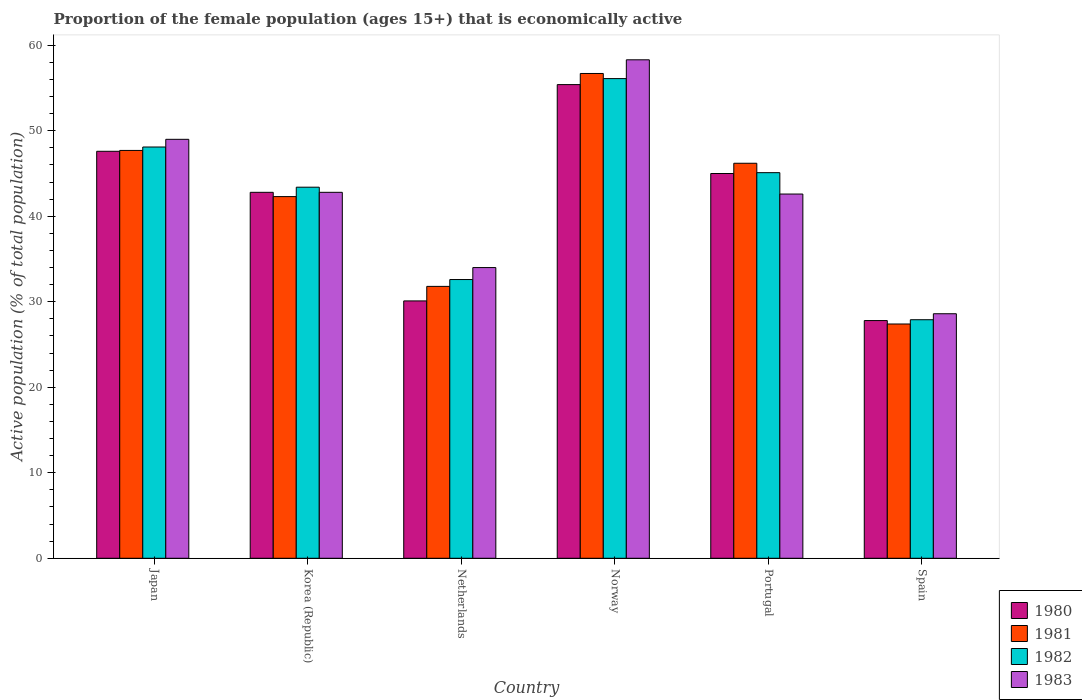How many different coloured bars are there?
Offer a terse response. 4. How many groups of bars are there?
Make the answer very short. 6. Are the number of bars per tick equal to the number of legend labels?
Offer a terse response. Yes. How many bars are there on the 3rd tick from the right?
Ensure brevity in your answer.  4. What is the label of the 6th group of bars from the left?
Offer a very short reply. Spain. In how many cases, is the number of bars for a given country not equal to the number of legend labels?
Offer a terse response. 0. What is the proportion of the female population that is economically active in 1983 in Netherlands?
Your response must be concise. 34. Across all countries, what is the maximum proportion of the female population that is economically active in 1980?
Offer a very short reply. 55.4. Across all countries, what is the minimum proportion of the female population that is economically active in 1983?
Provide a succinct answer. 28.6. In which country was the proportion of the female population that is economically active in 1982 minimum?
Your answer should be very brief. Spain. What is the total proportion of the female population that is economically active in 1982 in the graph?
Offer a very short reply. 253.2. What is the difference between the proportion of the female population that is economically active in 1981 in Norway and that in Portugal?
Provide a succinct answer. 10.5. What is the difference between the proportion of the female population that is economically active in 1983 in Portugal and the proportion of the female population that is economically active in 1980 in Korea (Republic)?
Your response must be concise. -0.2. What is the average proportion of the female population that is economically active in 1981 per country?
Your answer should be compact. 42.02. What is the difference between the proportion of the female population that is economically active of/in 1980 and proportion of the female population that is economically active of/in 1981 in Japan?
Make the answer very short. -0.1. What is the ratio of the proportion of the female population that is economically active in 1983 in Korea (Republic) to that in Norway?
Keep it short and to the point. 0.73. Is the proportion of the female population that is economically active in 1982 in Japan less than that in Spain?
Your answer should be very brief. No. What is the difference between the highest and the second highest proportion of the female population that is economically active in 1983?
Offer a terse response. -9.3. What is the difference between the highest and the lowest proportion of the female population that is economically active in 1982?
Your answer should be compact. 28.2. Is it the case that in every country, the sum of the proportion of the female population that is economically active in 1983 and proportion of the female population that is economically active in 1982 is greater than the sum of proportion of the female population that is economically active in 1980 and proportion of the female population that is economically active in 1981?
Keep it short and to the point. No. What does the 1st bar from the right in Netherlands represents?
Make the answer very short. 1983. How many bars are there?
Offer a very short reply. 24. Are all the bars in the graph horizontal?
Your answer should be very brief. No. How many countries are there in the graph?
Offer a terse response. 6. What is the difference between two consecutive major ticks on the Y-axis?
Offer a terse response. 10. Does the graph contain grids?
Give a very brief answer. No. How many legend labels are there?
Offer a terse response. 4. What is the title of the graph?
Provide a succinct answer. Proportion of the female population (ages 15+) that is economically active. Does "1986" appear as one of the legend labels in the graph?
Provide a short and direct response. No. What is the label or title of the Y-axis?
Provide a succinct answer. Active population (% of total population). What is the Active population (% of total population) in 1980 in Japan?
Offer a terse response. 47.6. What is the Active population (% of total population) in 1981 in Japan?
Offer a very short reply. 47.7. What is the Active population (% of total population) in 1982 in Japan?
Provide a succinct answer. 48.1. What is the Active population (% of total population) of 1983 in Japan?
Your answer should be very brief. 49. What is the Active population (% of total population) in 1980 in Korea (Republic)?
Provide a succinct answer. 42.8. What is the Active population (% of total population) of 1981 in Korea (Republic)?
Make the answer very short. 42.3. What is the Active population (% of total population) of 1982 in Korea (Republic)?
Make the answer very short. 43.4. What is the Active population (% of total population) in 1983 in Korea (Republic)?
Offer a terse response. 42.8. What is the Active population (% of total population) of 1980 in Netherlands?
Provide a short and direct response. 30.1. What is the Active population (% of total population) in 1981 in Netherlands?
Offer a terse response. 31.8. What is the Active population (% of total population) in 1982 in Netherlands?
Your answer should be very brief. 32.6. What is the Active population (% of total population) of 1983 in Netherlands?
Offer a terse response. 34. What is the Active population (% of total population) in 1980 in Norway?
Make the answer very short. 55.4. What is the Active population (% of total population) in 1981 in Norway?
Your answer should be very brief. 56.7. What is the Active population (% of total population) of 1982 in Norway?
Your answer should be compact. 56.1. What is the Active population (% of total population) of 1983 in Norway?
Your response must be concise. 58.3. What is the Active population (% of total population) in 1980 in Portugal?
Ensure brevity in your answer.  45. What is the Active population (% of total population) in 1981 in Portugal?
Offer a terse response. 46.2. What is the Active population (% of total population) in 1982 in Portugal?
Keep it short and to the point. 45.1. What is the Active population (% of total population) in 1983 in Portugal?
Your answer should be very brief. 42.6. What is the Active population (% of total population) in 1980 in Spain?
Your response must be concise. 27.8. What is the Active population (% of total population) in 1981 in Spain?
Your response must be concise. 27.4. What is the Active population (% of total population) of 1982 in Spain?
Your answer should be compact. 27.9. What is the Active population (% of total population) of 1983 in Spain?
Give a very brief answer. 28.6. Across all countries, what is the maximum Active population (% of total population) of 1980?
Your answer should be very brief. 55.4. Across all countries, what is the maximum Active population (% of total population) of 1981?
Your answer should be very brief. 56.7. Across all countries, what is the maximum Active population (% of total population) in 1982?
Give a very brief answer. 56.1. Across all countries, what is the maximum Active population (% of total population) of 1983?
Your answer should be very brief. 58.3. Across all countries, what is the minimum Active population (% of total population) of 1980?
Make the answer very short. 27.8. Across all countries, what is the minimum Active population (% of total population) in 1981?
Your response must be concise. 27.4. Across all countries, what is the minimum Active population (% of total population) in 1982?
Keep it short and to the point. 27.9. Across all countries, what is the minimum Active population (% of total population) in 1983?
Keep it short and to the point. 28.6. What is the total Active population (% of total population) of 1980 in the graph?
Offer a very short reply. 248.7. What is the total Active population (% of total population) in 1981 in the graph?
Make the answer very short. 252.1. What is the total Active population (% of total population) of 1982 in the graph?
Your response must be concise. 253.2. What is the total Active population (% of total population) in 1983 in the graph?
Offer a terse response. 255.3. What is the difference between the Active population (% of total population) of 1981 in Japan and that in Korea (Republic)?
Your answer should be compact. 5.4. What is the difference between the Active population (% of total population) of 1982 in Japan and that in Korea (Republic)?
Offer a terse response. 4.7. What is the difference between the Active population (% of total population) in 1983 in Japan and that in Korea (Republic)?
Offer a terse response. 6.2. What is the difference between the Active population (% of total population) of 1981 in Japan and that in Netherlands?
Give a very brief answer. 15.9. What is the difference between the Active population (% of total population) in 1982 in Japan and that in Netherlands?
Give a very brief answer. 15.5. What is the difference between the Active population (% of total population) in 1981 in Japan and that in Norway?
Offer a terse response. -9. What is the difference between the Active population (% of total population) of 1982 in Japan and that in Norway?
Offer a very short reply. -8. What is the difference between the Active population (% of total population) in 1983 in Japan and that in Norway?
Make the answer very short. -9.3. What is the difference between the Active population (% of total population) of 1980 in Japan and that in Portugal?
Make the answer very short. 2.6. What is the difference between the Active population (% of total population) in 1981 in Japan and that in Portugal?
Offer a terse response. 1.5. What is the difference between the Active population (% of total population) in 1982 in Japan and that in Portugal?
Provide a succinct answer. 3. What is the difference between the Active population (% of total population) in 1980 in Japan and that in Spain?
Give a very brief answer. 19.8. What is the difference between the Active population (% of total population) in 1981 in Japan and that in Spain?
Your answer should be very brief. 20.3. What is the difference between the Active population (% of total population) of 1982 in Japan and that in Spain?
Give a very brief answer. 20.2. What is the difference between the Active population (% of total population) in 1983 in Japan and that in Spain?
Your response must be concise. 20.4. What is the difference between the Active population (% of total population) of 1981 in Korea (Republic) and that in Netherlands?
Your response must be concise. 10.5. What is the difference between the Active population (% of total population) in 1983 in Korea (Republic) and that in Netherlands?
Keep it short and to the point. 8.8. What is the difference between the Active population (% of total population) in 1981 in Korea (Republic) and that in Norway?
Provide a succinct answer. -14.4. What is the difference between the Active population (% of total population) in 1983 in Korea (Republic) and that in Norway?
Offer a terse response. -15.5. What is the difference between the Active population (% of total population) of 1980 in Korea (Republic) and that in Portugal?
Offer a very short reply. -2.2. What is the difference between the Active population (% of total population) in 1980 in Korea (Republic) and that in Spain?
Your answer should be very brief. 15. What is the difference between the Active population (% of total population) in 1981 in Korea (Republic) and that in Spain?
Your answer should be very brief. 14.9. What is the difference between the Active population (% of total population) of 1982 in Korea (Republic) and that in Spain?
Provide a short and direct response. 15.5. What is the difference between the Active population (% of total population) of 1980 in Netherlands and that in Norway?
Provide a succinct answer. -25.3. What is the difference between the Active population (% of total population) of 1981 in Netherlands and that in Norway?
Provide a short and direct response. -24.9. What is the difference between the Active population (% of total population) of 1982 in Netherlands and that in Norway?
Make the answer very short. -23.5. What is the difference between the Active population (% of total population) in 1983 in Netherlands and that in Norway?
Your answer should be compact. -24.3. What is the difference between the Active population (% of total population) in 1980 in Netherlands and that in Portugal?
Offer a terse response. -14.9. What is the difference between the Active population (% of total population) of 1981 in Netherlands and that in Portugal?
Make the answer very short. -14.4. What is the difference between the Active population (% of total population) in 1982 in Netherlands and that in Portugal?
Offer a very short reply. -12.5. What is the difference between the Active population (% of total population) in 1983 in Netherlands and that in Portugal?
Provide a short and direct response. -8.6. What is the difference between the Active population (% of total population) in 1982 in Netherlands and that in Spain?
Provide a succinct answer. 4.7. What is the difference between the Active population (% of total population) in 1983 in Norway and that in Portugal?
Your answer should be very brief. 15.7. What is the difference between the Active population (% of total population) of 1980 in Norway and that in Spain?
Keep it short and to the point. 27.6. What is the difference between the Active population (% of total population) in 1981 in Norway and that in Spain?
Offer a very short reply. 29.3. What is the difference between the Active population (% of total population) in 1982 in Norway and that in Spain?
Offer a terse response. 28.2. What is the difference between the Active population (% of total population) of 1983 in Norway and that in Spain?
Your answer should be very brief. 29.7. What is the difference between the Active population (% of total population) in 1982 in Portugal and that in Spain?
Keep it short and to the point. 17.2. What is the difference between the Active population (% of total population) of 1983 in Portugal and that in Spain?
Offer a terse response. 14. What is the difference between the Active population (% of total population) of 1980 in Japan and the Active population (% of total population) of 1982 in Korea (Republic)?
Make the answer very short. 4.2. What is the difference between the Active population (% of total population) of 1981 in Japan and the Active population (% of total population) of 1982 in Korea (Republic)?
Your answer should be compact. 4.3. What is the difference between the Active population (% of total population) of 1981 in Japan and the Active population (% of total population) of 1983 in Korea (Republic)?
Your answer should be very brief. 4.9. What is the difference between the Active population (% of total population) of 1980 in Japan and the Active population (% of total population) of 1982 in Netherlands?
Make the answer very short. 15. What is the difference between the Active population (% of total population) in 1980 in Japan and the Active population (% of total population) in 1983 in Netherlands?
Keep it short and to the point. 13.6. What is the difference between the Active population (% of total population) in 1981 in Japan and the Active population (% of total population) in 1982 in Netherlands?
Provide a short and direct response. 15.1. What is the difference between the Active population (% of total population) in 1980 in Japan and the Active population (% of total population) in 1981 in Norway?
Provide a short and direct response. -9.1. What is the difference between the Active population (% of total population) of 1980 in Japan and the Active population (% of total population) of 1982 in Norway?
Make the answer very short. -8.5. What is the difference between the Active population (% of total population) in 1981 in Japan and the Active population (% of total population) in 1982 in Norway?
Provide a short and direct response. -8.4. What is the difference between the Active population (% of total population) of 1981 in Japan and the Active population (% of total population) of 1983 in Norway?
Your answer should be very brief. -10.6. What is the difference between the Active population (% of total population) in 1980 in Japan and the Active population (% of total population) in 1981 in Portugal?
Keep it short and to the point. 1.4. What is the difference between the Active population (% of total population) in 1981 in Japan and the Active population (% of total population) in 1983 in Portugal?
Your response must be concise. 5.1. What is the difference between the Active population (% of total population) in 1982 in Japan and the Active population (% of total population) in 1983 in Portugal?
Offer a very short reply. 5.5. What is the difference between the Active population (% of total population) in 1980 in Japan and the Active population (% of total population) in 1981 in Spain?
Make the answer very short. 20.2. What is the difference between the Active population (% of total population) of 1981 in Japan and the Active population (% of total population) of 1982 in Spain?
Offer a very short reply. 19.8. What is the difference between the Active population (% of total population) in 1982 in Japan and the Active population (% of total population) in 1983 in Spain?
Your answer should be very brief. 19.5. What is the difference between the Active population (% of total population) in 1980 in Korea (Republic) and the Active population (% of total population) in 1982 in Netherlands?
Keep it short and to the point. 10.2. What is the difference between the Active population (% of total population) of 1980 in Korea (Republic) and the Active population (% of total population) of 1981 in Norway?
Keep it short and to the point. -13.9. What is the difference between the Active population (% of total population) of 1980 in Korea (Republic) and the Active population (% of total population) of 1983 in Norway?
Keep it short and to the point. -15.5. What is the difference between the Active population (% of total population) of 1982 in Korea (Republic) and the Active population (% of total population) of 1983 in Norway?
Give a very brief answer. -14.9. What is the difference between the Active population (% of total population) of 1980 in Korea (Republic) and the Active population (% of total population) of 1983 in Portugal?
Provide a short and direct response. 0.2. What is the difference between the Active population (% of total population) in 1981 in Korea (Republic) and the Active population (% of total population) in 1982 in Portugal?
Offer a very short reply. -2.8. What is the difference between the Active population (% of total population) in 1981 in Korea (Republic) and the Active population (% of total population) in 1983 in Portugal?
Your answer should be very brief. -0.3. What is the difference between the Active population (% of total population) in 1980 in Korea (Republic) and the Active population (% of total population) in 1981 in Spain?
Offer a very short reply. 15.4. What is the difference between the Active population (% of total population) of 1980 in Korea (Republic) and the Active population (% of total population) of 1982 in Spain?
Your answer should be compact. 14.9. What is the difference between the Active population (% of total population) in 1981 in Korea (Republic) and the Active population (% of total population) in 1983 in Spain?
Your response must be concise. 13.7. What is the difference between the Active population (% of total population) in 1982 in Korea (Republic) and the Active population (% of total population) in 1983 in Spain?
Your answer should be very brief. 14.8. What is the difference between the Active population (% of total population) of 1980 in Netherlands and the Active population (% of total population) of 1981 in Norway?
Your answer should be compact. -26.6. What is the difference between the Active population (% of total population) in 1980 in Netherlands and the Active population (% of total population) in 1983 in Norway?
Provide a succinct answer. -28.2. What is the difference between the Active population (% of total population) of 1981 in Netherlands and the Active population (% of total population) of 1982 in Norway?
Your response must be concise. -24.3. What is the difference between the Active population (% of total population) of 1981 in Netherlands and the Active population (% of total population) of 1983 in Norway?
Give a very brief answer. -26.5. What is the difference between the Active population (% of total population) in 1982 in Netherlands and the Active population (% of total population) in 1983 in Norway?
Ensure brevity in your answer.  -25.7. What is the difference between the Active population (% of total population) in 1980 in Netherlands and the Active population (% of total population) in 1981 in Portugal?
Provide a succinct answer. -16.1. What is the difference between the Active population (% of total population) of 1980 in Netherlands and the Active population (% of total population) of 1982 in Portugal?
Offer a very short reply. -15. What is the difference between the Active population (% of total population) in 1980 in Netherlands and the Active population (% of total population) in 1983 in Portugal?
Offer a terse response. -12.5. What is the difference between the Active population (% of total population) in 1981 in Netherlands and the Active population (% of total population) in 1983 in Portugal?
Provide a succinct answer. -10.8. What is the difference between the Active population (% of total population) in 1982 in Netherlands and the Active population (% of total population) in 1983 in Portugal?
Make the answer very short. -10. What is the difference between the Active population (% of total population) in 1980 in Netherlands and the Active population (% of total population) in 1983 in Spain?
Keep it short and to the point. 1.5. What is the difference between the Active population (% of total population) in 1982 in Netherlands and the Active population (% of total population) in 1983 in Spain?
Your answer should be very brief. 4. What is the difference between the Active population (% of total population) of 1980 in Norway and the Active population (% of total population) of 1982 in Portugal?
Give a very brief answer. 10.3. What is the difference between the Active population (% of total population) in 1980 in Norway and the Active population (% of total population) in 1983 in Portugal?
Ensure brevity in your answer.  12.8. What is the difference between the Active population (% of total population) of 1981 in Norway and the Active population (% of total population) of 1983 in Portugal?
Provide a short and direct response. 14.1. What is the difference between the Active population (% of total population) of 1980 in Norway and the Active population (% of total population) of 1981 in Spain?
Keep it short and to the point. 28. What is the difference between the Active population (% of total population) in 1980 in Norway and the Active population (% of total population) in 1983 in Spain?
Give a very brief answer. 26.8. What is the difference between the Active population (% of total population) of 1981 in Norway and the Active population (% of total population) of 1982 in Spain?
Offer a very short reply. 28.8. What is the difference between the Active population (% of total population) in 1981 in Norway and the Active population (% of total population) in 1983 in Spain?
Your answer should be very brief. 28.1. What is the difference between the Active population (% of total population) of 1980 in Portugal and the Active population (% of total population) of 1981 in Spain?
Offer a terse response. 17.6. What is the difference between the Active population (% of total population) in 1980 in Portugal and the Active population (% of total population) in 1982 in Spain?
Ensure brevity in your answer.  17.1. What is the difference between the Active population (% of total population) of 1981 in Portugal and the Active population (% of total population) of 1983 in Spain?
Your response must be concise. 17.6. What is the average Active population (% of total population) of 1980 per country?
Your answer should be very brief. 41.45. What is the average Active population (% of total population) of 1981 per country?
Offer a terse response. 42.02. What is the average Active population (% of total population) of 1982 per country?
Provide a succinct answer. 42.2. What is the average Active population (% of total population) in 1983 per country?
Your response must be concise. 42.55. What is the difference between the Active population (% of total population) of 1980 and Active population (% of total population) of 1981 in Japan?
Offer a terse response. -0.1. What is the difference between the Active population (% of total population) of 1980 and Active population (% of total population) of 1982 in Japan?
Make the answer very short. -0.5. What is the difference between the Active population (% of total population) in 1980 and Active population (% of total population) in 1983 in Japan?
Ensure brevity in your answer.  -1.4. What is the difference between the Active population (% of total population) in 1981 and Active population (% of total population) in 1983 in Japan?
Provide a short and direct response. -1.3. What is the difference between the Active population (% of total population) in 1982 and Active population (% of total population) in 1983 in Japan?
Provide a succinct answer. -0.9. What is the difference between the Active population (% of total population) in 1980 and Active population (% of total population) in 1983 in Korea (Republic)?
Keep it short and to the point. 0. What is the difference between the Active population (% of total population) of 1981 and Active population (% of total population) of 1982 in Korea (Republic)?
Make the answer very short. -1.1. What is the difference between the Active population (% of total population) of 1982 and Active population (% of total population) of 1983 in Korea (Republic)?
Provide a succinct answer. 0.6. What is the difference between the Active population (% of total population) of 1980 and Active population (% of total population) of 1982 in Netherlands?
Offer a very short reply. -2.5. What is the difference between the Active population (% of total population) of 1981 and Active population (% of total population) of 1982 in Netherlands?
Your response must be concise. -0.8. What is the difference between the Active population (% of total population) in 1981 and Active population (% of total population) in 1983 in Netherlands?
Make the answer very short. -2.2. What is the difference between the Active population (% of total population) in 1982 and Active population (% of total population) in 1983 in Netherlands?
Provide a succinct answer. -1.4. What is the difference between the Active population (% of total population) of 1980 and Active population (% of total population) of 1981 in Norway?
Offer a terse response. -1.3. What is the difference between the Active population (% of total population) of 1981 and Active population (% of total population) of 1983 in Norway?
Your answer should be compact. -1.6. What is the difference between the Active population (% of total population) in 1982 and Active population (% of total population) in 1983 in Norway?
Make the answer very short. -2.2. What is the difference between the Active population (% of total population) of 1980 and Active population (% of total population) of 1983 in Portugal?
Your response must be concise. 2.4. What is the difference between the Active population (% of total population) in 1981 and Active population (% of total population) in 1983 in Portugal?
Your answer should be very brief. 3.6. What is the difference between the Active population (% of total population) of 1982 and Active population (% of total population) of 1983 in Portugal?
Make the answer very short. 2.5. What is the difference between the Active population (% of total population) in 1981 and Active population (% of total population) in 1982 in Spain?
Your response must be concise. -0.5. What is the difference between the Active population (% of total population) of 1981 and Active population (% of total population) of 1983 in Spain?
Ensure brevity in your answer.  -1.2. What is the difference between the Active population (% of total population) of 1982 and Active population (% of total population) of 1983 in Spain?
Give a very brief answer. -0.7. What is the ratio of the Active population (% of total population) of 1980 in Japan to that in Korea (Republic)?
Keep it short and to the point. 1.11. What is the ratio of the Active population (% of total population) in 1981 in Japan to that in Korea (Republic)?
Give a very brief answer. 1.13. What is the ratio of the Active population (% of total population) in 1982 in Japan to that in Korea (Republic)?
Give a very brief answer. 1.11. What is the ratio of the Active population (% of total population) in 1983 in Japan to that in Korea (Republic)?
Provide a short and direct response. 1.14. What is the ratio of the Active population (% of total population) in 1980 in Japan to that in Netherlands?
Ensure brevity in your answer.  1.58. What is the ratio of the Active population (% of total population) of 1982 in Japan to that in Netherlands?
Make the answer very short. 1.48. What is the ratio of the Active population (% of total population) of 1983 in Japan to that in Netherlands?
Keep it short and to the point. 1.44. What is the ratio of the Active population (% of total population) of 1980 in Japan to that in Norway?
Give a very brief answer. 0.86. What is the ratio of the Active population (% of total population) of 1981 in Japan to that in Norway?
Provide a succinct answer. 0.84. What is the ratio of the Active population (% of total population) in 1982 in Japan to that in Norway?
Provide a succinct answer. 0.86. What is the ratio of the Active population (% of total population) of 1983 in Japan to that in Norway?
Provide a short and direct response. 0.84. What is the ratio of the Active population (% of total population) of 1980 in Japan to that in Portugal?
Provide a short and direct response. 1.06. What is the ratio of the Active population (% of total population) of 1981 in Japan to that in Portugal?
Provide a short and direct response. 1.03. What is the ratio of the Active population (% of total population) of 1982 in Japan to that in Portugal?
Offer a very short reply. 1.07. What is the ratio of the Active population (% of total population) of 1983 in Japan to that in Portugal?
Give a very brief answer. 1.15. What is the ratio of the Active population (% of total population) in 1980 in Japan to that in Spain?
Provide a short and direct response. 1.71. What is the ratio of the Active population (% of total population) in 1981 in Japan to that in Spain?
Keep it short and to the point. 1.74. What is the ratio of the Active population (% of total population) in 1982 in Japan to that in Spain?
Provide a succinct answer. 1.72. What is the ratio of the Active population (% of total population) of 1983 in Japan to that in Spain?
Offer a terse response. 1.71. What is the ratio of the Active population (% of total population) of 1980 in Korea (Republic) to that in Netherlands?
Your answer should be compact. 1.42. What is the ratio of the Active population (% of total population) of 1981 in Korea (Republic) to that in Netherlands?
Offer a very short reply. 1.33. What is the ratio of the Active population (% of total population) in 1982 in Korea (Republic) to that in Netherlands?
Give a very brief answer. 1.33. What is the ratio of the Active population (% of total population) of 1983 in Korea (Republic) to that in Netherlands?
Give a very brief answer. 1.26. What is the ratio of the Active population (% of total population) of 1980 in Korea (Republic) to that in Norway?
Provide a short and direct response. 0.77. What is the ratio of the Active population (% of total population) of 1981 in Korea (Republic) to that in Norway?
Give a very brief answer. 0.75. What is the ratio of the Active population (% of total population) in 1982 in Korea (Republic) to that in Norway?
Keep it short and to the point. 0.77. What is the ratio of the Active population (% of total population) of 1983 in Korea (Republic) to that in Norway?
Your response must be concise. 0.73. What is the ratio of the Active population (% of total population) in 1980 in Korea (Republic) to that in Portugal?
Ensure brevity in your answer.  0.95. What is the ratio of the Active population (% of total population) of 1981 in Korea (Republic) to that in Portugal?
Offer a terse response. 0.92. What is the ratio of the Active population (% of total population) of 1982 in Korea (Republic) to that in Portugal?
Ensure brevity in your answer.  0.96. What is the ratio of the Active population (% of total population) of 1983 in Korea (Republic) to that in Portugal?
Offer a terse response. 1. What is the ratio of the Active population (% of total population) in 1980 in Korea (Republic) to that in Spain?
Ensure brevity in your answer.  1.54. What is the ratio of the Active population (% of total population) of 1981 in Korea (Republic) to that in Spain?
Provide a succinct answer. 1.54. What is the ratio of the Active population (% of total population) of 1982 in Korea (Republic) to that in Spain?
Keep it short and to the point. 1.56. What is the ratio of the Active population (% of total population) in 1983 in Korea (Republic) to that in Spain?
Provide a succinct answer. 1.5. What is the ratio of the Active population (% of total population) in 1980 in Netherlands to that in Norway?
Keep it short and to the point. 0.54. What is the ratio of the Active population (% of total population) in 1981 in Netherlands to that in Norway?
Your answer should be compact. 0.56. What is the ratio of the Active population (% of total population) in 1982 in Netherlands to that in Norway?
Make the answer very short. 0.58. What is the ratio of the Active population (% of total population) in 1983 in Netherlands to that in Norway?
Your answer should be very brief. 0.58. What is the ratio of the Active population (% of total population) in 1980 in Netherlands to that in Portugal?
Your answer should be very brief. 0.67. What is the ratio of the Active population (% of total population) of 1981 in Netherlands to that in Portugal?
Your response must be concise. 0.69. What is the ratio of the Active population (% of total population) in 1982 in Netherlands to that in Portugal?
Your response must be concise. 0.72. What is the ratio of the Active population (% of total population) of 1983 in Netherlands to that in Portugal?
Offer a terse response. 0.8. What is the ratio of the Active population (% of total population) in 1980 in Netherlands to that in Spain?
Provide a succinct answer. 1.08. What is the ratio of the Active population (% of total population) of 1981 in Netherlands to that in Spain?
Your answer should be compact. 1.16. What is the ratio of the Active population (% of total population) in 1982 in Netherlands to that in Spain?
Ensure brevity in your answer.  1.17. What is the ratio of the Active population (% of total population) in 1983 in Netherlands to that in Spain?
Keep it short and to the point. 1.19. What is the ratio of the Active population (% of total population) in 1980 in Norway to that in Portugal?
Your answer should be compact. 1.23. What is the ratio of the Active population (% of total population) of 1981 in Norway to that in Portugal?
Offer a terse response. 1.23. What is the ratio of the Active population (% of total population) in 1982 in Norway to that in Portugal?
Give a very brief answer. 1.24. What is the ratio of the Active population (% of total population) of 1983 in Norway to that in Portugal?
Your response must be concise. 1.37. What is the ratio of the Active population (% of total population) of 1980 in Norway to that in Spain?
Give a very brief answer. 1.99. What is the ratio of the Active population (% of total population) in 1981 in Norway to that in Spain?
Make the answer very short. 2.07. What is the ratio of the Active population (% of total population) in 1982 in Norway to that in Spain?
Provide a succinct answer. 2.01. What is the ratio of the Active population (% of total population) in 1983 in Norway to that in Spain?
Your answer should be compact. 2.04. What is the ratio of the Active population (% of total population) of 1980 in Portugal to that in Spain?
Offer a terse response. 1.62. What is the ratio of the Active population (% of total population) in 1981 in Portugal to that in Spain?
Your answer should be compact. 1.69. What is the ratio of the Active population (% of total population) of 1982 in Portugal to that in Spain?
Your answer should be compact. 1.62. What is the ratio of the Active population (% of total population) in 1983 in Portugal to that in Spain?
Offer a very short reply. 1.49. What is the difference between the highest and the lowest Active population (% of total population) in 1980?
Provide a succinct answer. 27.6. What is the difference between the highest and the lowest Active population (% of total population) in 1981?
Give a very brief answer. 29.3. What is the difference between the highest and the lowest Active population (% of total population) in 1982?
Give a very brief answer. 28.2. What is the difference between the highest and the lowest Active population (% of total population) in 1983?
Provide a succinct answer. 29.7. 